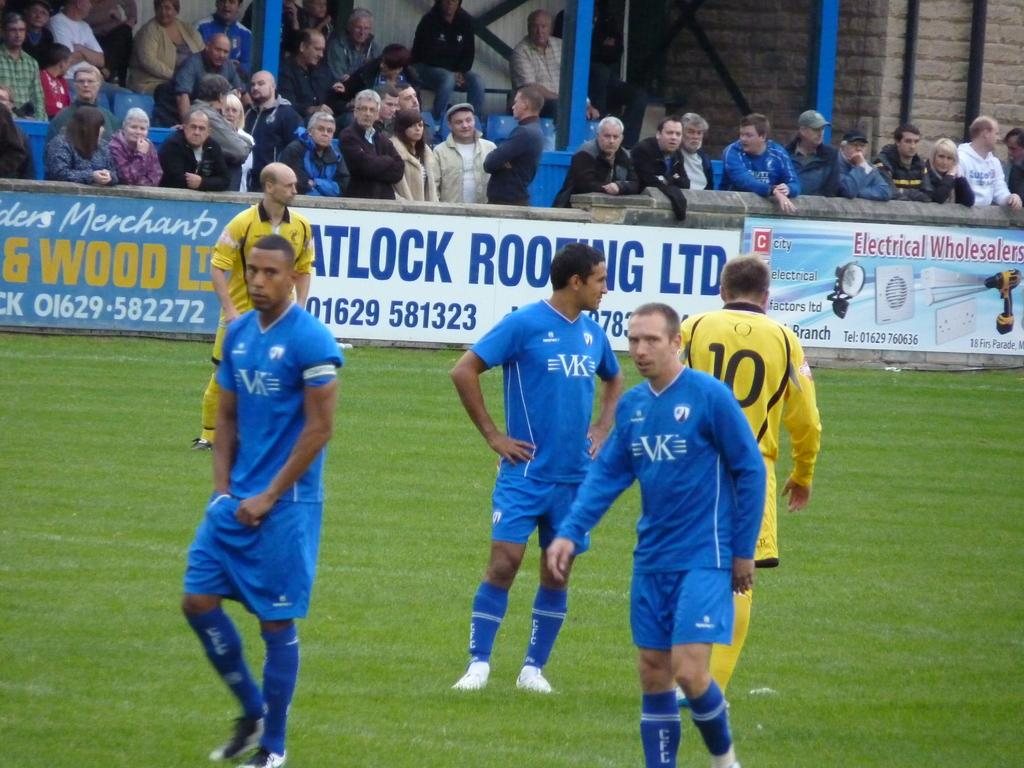What are the people in the image doing? The people in the image are standing on the ground. What can be seen in the background of the image? There is a wall, advertising boards, people, and poles in the background of the image. What type of salt can be seen on the tongue of the person in the image? There is no salt or tongue visible in the image; it only shows people standing on the ground and elements in the background. 